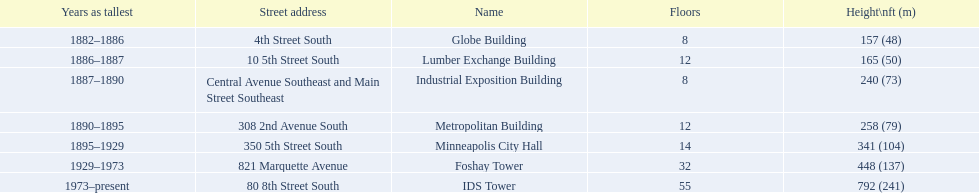After ids tower what is the second tallest building in minneapolis? Foshay Tower. 